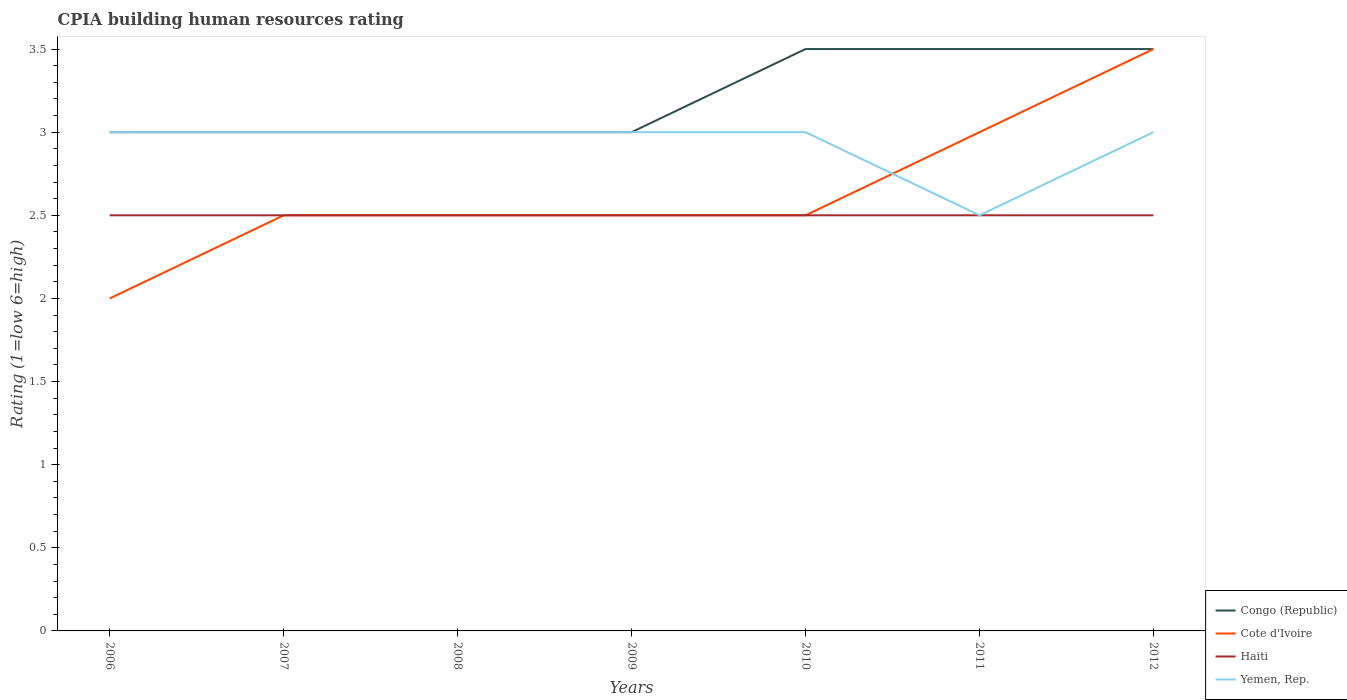Is the number of lines equal to the number of legend labels?
Provide a short and direct response. Yes. What is the total CPIA rating in Haiti in the graph?
Your answer should be very brief. 0. What is the difference between the highest and the second highest CPIA rating in Yemen, Rep.?
Offer a very short reply. 0.5. What is the difference between the highest and the lowest CPIA rating in Haiti?
Give a very brief answer. 0. How many years are there in the graph?
Offer a very short reply. 7. Does the graph contain grids?
Your answer should be compact. No. Where does the legend appear in the graph?
Offer a very short reply. Bottom right. What is the title of the graph?
Offer a very short reply. CPIA building human resources rating. What is the label or title of the X-axis?
Keep it short and to the point. Years. What is the label or title of the Y-axis?
Your response must be concise. Rating (1=low 6=high). What is the Rating (1=low 6=high) of Congo (Republic) in 2006?
Keep it short and to the point. 3. What is the Rating (1=low 6=high) in Cote d'Ivoire in 2006?
Keep it short and to the point. 2. What is the Rating (1=low 6=high) of Haiti in 2006?
Provide a short and direct response. 2.5. What is the Rating (1=low 6=high) in Yemen, Rep. in 2006?
Provide a succinct answer. 3. What is the Rating (1=low 6=high) of Congo (Republic) in 2007?
Your answer should be compact. 3. What is the Rating (1=low 6=high) in Cote d'Ivoire in 2007?
Ensure brevity in your answer.  2.5. What is the Rating (1=low 6=high) in Haiti in 2007?
Provide a short and direct response. 2.5. What is the Rating (1=low 6=high) in Congo (Republic) in 2008?
Your answer should be very brief. 3. What is the Rating (1=low 6=high) of Haiti in 2008?
Make the answer very short. 2.5. What is the Rating (1=low 6=high) in Yemen, Rep. in 2008?
Provide a succinct answer. 3. What is the Rating (1=low 6=high) in Congo (Republic) in 2009?
Your response must be concise. 3. What is the Rating (1=low 6=high) in Cote d'Ivoire in 2009?
Ensure brevity in your answer.  2.5. What is the Rating (1=low 6=high) in Yemen, Rep. in 2009?
Keep it short and to the point. 3. What is the Rating (1=low 6=high) in Congo (Republic) in 2011?
Your answer should be compact. 3.5. What is the Rating (1=low 6=high) of Cote d'Ivoire in 2011?
Make the answer very short. 3. What is the Rating (1=low 6=high) in Haiti in 2011?
Your answer should be very brief. 2.5. What is the Rating (1=low 6=high) of Yemen, Rep. in 2011?
Offer a terse response. 2.5. What is the Rating (1=low 6=high) in Cote d'Ivoire in 2012?
Offer a terse response. 3.5. What is the Rating (1=low 6=high) in Yemen, Rep. in 2012?
Give a very brief answer. 3. Across all years, what is the maximum Rating (1=low 6=high) in Yemen, Rep.?
Your answer should be very brief. 3. Across all years, what is the minimum Rating (1=low 6=high) of Cote d'Ivoire?
Keep it short and to the point. 2. Across all years, what is the minimum Rating (1=low 6=high) in Haiti?
Make the answer very short. 2.5. What is the total Rating (1=low 6=high) in Yemen, Rep. in the graph?
Keep it short and to the point. 20.5. What is the difference between the Rating (1=low 6=high) in Cote d'Ivoire in 2006 and that in 2007?
Your answer should be very brief. -0.5. What is the difference between the Rating (1=low 6=high) of Cote d'Ivoire in 2006 and that in 2008?
Your answer should be very brief. -0.5. What is the difference between the Rating (1=low 6=high) of Congo (Republic) in 2006 and that in 2009?
Ensure brevity in your answer.  0. What is the difference between the Rating (1=low 6=high) of Haiti in 2006 and that in 2009?
Provide a short and direct response. 0. What is the difference between the Rating (1=low 6=high) of Yemen, Rep. in 2006 and that in 2009?
Offer a very short reply. 0. What is the difference between the Rating (1=low 6=high) in Congo (Republic) in 2006 and that in 2010?
Provide a succinct answer. -0.5. What is the difference between the Rating (1=low 6=high) in Cote d'Ivoire in 2006 and that in 2010?
Offer a very short reply. -0.5. What is the difference between the Rating (1=low 6=high) in Yemen, Rep. in 2006 and that in 2010?
Your answer should be very brief. 0. What is the difference between the Rating (1=low 6=high) of Congo (Republic) in 2006 and that in 2011?
Your answer should be compact. -0.5. What is the difference between the Rating (1=low 6=high) of Cote d'Ivoire in 2006 and that in 2011?
Keep it short and to the point. -1. What is the difference between the Rating (1=low 6=high) in Congo (Republic) in 2006 and that in 2012?
Your response must be concise. -0.5. What is the difference between the Rating (1=low 6=high) in Cote d'Ivoire in 2006 and that in 2012?
Ensure brevity in your answer.  -1.5. What is the difference between the Rating (1=low 6=high) in Haiti in 2006 and that in 2012?
Keep it short and to the point. 0. What is the difference between the Rating (1=low 6=high) in Yemen, Rep. in 2006 and that in 2012?
Give a very brief answer. 0. What is the difference between the Rating (1=low 6=high) in Congo (Republic) in 2007 and that in 2008?
Your answer should be very brief. 0. What is the difference between the Rating (1=low 6=high) of Haiti in 2007 and that in 2008?
Give a very brief answer. 0. What is the difference between the Rating (1=low 6=high) of Congo (Republic) in 2007 and that in 2009?
Offer a terse response. 0. What is the difference between the Rating (1=low 6=high) of Congo (Republic) in 2007 and that in 2010?
Offer a terse response. -0.5. What is the difference between the Rating (1=low 6=high) of Yemen, Rep. in 2007 and that in 2010?
Your answer should be compact. 0. What is the difference between the Rating (1=low 6=high) in Congo (Republic) in 2007 and that in 2011?
Your response must be concise. -0.5. What is the difference between the Rating (1=low 6=high) of Cote d'Ivoire in 2007 and that in 2012?
Offer a terse response. -1. What is the difference between the Rating (1=low 6=high) of Congo (Republic) in 2008 and that in 2009?
Make the answer very short. 0. What is the difference between the Rating (1=low 6=high) in Cote d'Ivoire in 2008 and that in 2009?
Provide a succinct answer. 0. What is the difference between the Rating (1=low 6=high) of Yemen, Rep. in 2008 and that in 2009?
Provide a short and direct response. 0. What is the difference between the Rating (1=low 6=high) of Yemen, Rep. in 2008 and that in 2010?
Ensure brevity in your answer.  0. What is the difference between the Rating (1=low 6=high) in Haiti in 2008 and that in 2011?
Provide a succinct answer. 0. What is the difference between the Rating (1=low 6=high) of Yemen, Rep. in 2008 and that in 2011?
Provide a succinct answer. 0.5. What is the difference between the Rating (1=low 6=high) of Congo (Republic) in 2008 and that in 2012?
Your answer should be compact. -0.5. What is the difference between the Rating (1=low 6=high) of Cote d'Ivoire in 2008 and that in 2012?
Ensure brevity in your answer.  -1. What is the difference between the Rating (1=low 6=high) in Yemen, Rep. in 2008 and that in 2012?
Make the answer very short. 0. What is the difference between the Rating (1=low 6=high) in Congo (Republic) in 2009 and that in 2010?
Your answer should be very brief. -0.5. What is the difference between the Rating (1=low 6=high) of Haiti in 2009 and that in 2010?
Make the answer very short. 0. What is the difference between the Rating (1=low 6=high) of Yemen, Rep. in 2009 and that in 2010?
Give a very brief answer. 0. What is the difference between the Rating (1=low 6=high) of Cote d'Ivoire in 2009 and that in 2011?
Provide a short and direct response. -0.5. What is the difference between the Rating (1=low 6=high) in Haiti in 2009 and that in 2011?
Your answer should be compact. 0. What is the difference between the Rating (1=low 6=high) of Yemen, Rep. in 2009 and that in 2011?
Keep it short and to the point. 0.5. What is the difference between the Rating (1=low 6=high) in Haiti in 2010 and that in 2011?
Provide a succinct answer. 0. What is the difference between the Rating (1=low 6=high) of Yemen, Rep. in 2010 and that in 2011?
Keep it short and to the point. 0.5. What is the difference between the Rating (1=low 6=high) of Congo (Republic) in 2010 and that in 2012?
Provide a short and direct response. 0. What is the difference between the Rating (1=low 6=high) in Cote d'Ivoire in 2010 and that in 2012?
Your answer should be very brief. -1. What is the difference between the Rating (1=low 6=high) in Haiti in 2010 and that in 2012?
Offer a very short reply. 0. What is the difference between the Rating (1=low 6=high) in Yemen, Rep. in 2010 and that in 2012?
Offer a very short reply. 0. What is the difference between the Rating (1=low 6=high) of Congo (Republic) in 2011 and that in 2012?
Your answer should be very brief. 0. What is the difference between the Rating (1=low 6=high) in Haiti in 2011 and that in 2012?
Offer a very short reply. 0. What is the difference between the Rating (1=low 6=high) of Congo (Republic) in 2006 and the Rating (1=low 6=high) of Cote d'Ivoire in 2007?
Ensure brevity in your answer.  0.5. What is the difference between the Rating (1=low 6=high) in Congo (Republic) in 2006 and the Rating (1=low 6=high) in Haiti in 2007?
Ensure brevity in your answer.  0.5. What is the difference between the Rating (1=low 6=high) of Congo (Republic) in 2006 and the Rating (1=low 6=high) of Yemen, Rep. in 2007?
Your answer should be compact. 0. What is the difference between the Rating (1=low 6=high) of Congo (Republic) in 2006 and the Rating (1=low 6=high) of Cote d'Ivoire in 2008?
Your response must be concise. 0.5. What is the difference between the Rating (1=low 6=high) in Congo (Republic) in 2006 and the Rating (1=low 6=high) in Haiti in 2008?
Provide a short and direct response. 0.5. What is the difference between the Rating (1=low 6=high) of Cote d'Ivoire in 2006 and the Rating (1=low 6=high) of Haiti in 2008?
Provide a short and direct response. -0.5. What is the difference between the Rating (1=low 6=high) of Cote d'Ivoire in 2006 and the Rating (1=low 6=high) of Yemen, Rep. in 2008?
Offer a very short reply. -1. What is the difference between the Rating (1=low 6=high) in Haiti in 2006 and the Rating (1=low 6=high) in Yemen, Rep. in 2008?
Your answer should be very brief. -0.5. What is the difference between the Rating (1=low 6=high) of Congo (Republic) in 2006 and the Rating (1=low 6=high) of Cote d'Ivoire in 2009?
Provide a short and direct response. 0.5. What is the difference between the Rating (1=low 6=high) of Congo (Republic) in 2006 and the Rating (1=low 6=high) of Haiti in 2009?
Offer a very short reply. 0.5. What is the difference between the Rating (1=low 6=high) in Cote d'Ivoire in 2006 and the Rating (1=low 6=high) in Haiti in 2009?
Give a very brief answer. -0.5. What is the difference between the Rating (1=low 6=high) of Congo (Republic) in 2006 and the Rating (1=low 6=high) of Haiti in 2010?
Your answer should be very brief. 0.5. What is the difference between the Rating (1=low 6=high) of Congo (Republic) in 2006 and the Rating (1=low 6=high) of Yemen, Rep. in 2010?
Offer a terse response. 0. What is the difference between the Rating (1=low 6=high) of Cote d'Ivoire in 2006 and the Rating (1=low 6=high) of Haiti in 2010?
Provide a succinct answer. -0.5. What is the difference between the Rating (1=low 6=high) of Cote d'Ivoire in 2006 and the Rating (1=low 6=high) of Yemen, Rep. in 2010?
Offer a terse response. -1. What is the difference between the Rating (1=low 6=high) of Haiti in 2006 and the Rating (1=low 6=high) of Yemen, Rep. in 2010?
Provide a succinct answer. -0.5. What is the difference between the Rating (1=low 6=high) of Congo (Republic) in 2006 and the Rating (1=low 6=high) of Cote d'Ivoire in 2011?
Your response must be concise. 0. What is the difference between the Rating (1=low 6=high) in Congo (Republic) in 2006 and the Rating (1=low 6=high) in Haiti in 2011?
Your answer should be compact. 0.5. What is the difference between the Rating (1=low 6=high) in Cote d'Ivoire in 2006 and the Rating (1=low 6=high) in Haiti in 2011?
Offer a terse response. -0.5. What is the difference between the Rating (1=low 6=high) in Cote d'Ivoire in 2006 and the Rating (1=low 6=high) in Yemen, Rep. in 2011?
Offer a very short reply. -0.5. What is the difference between the Rating (1=low 6=high) of Haiti in 2006 and the Rating (1=low 6=high) of Yemen, Rep. in 2011?
Your response must be concise. 0. What is the difference between the Rating (1=low 6=high) in Congo (Republic) in 2006 and the Rating (1=low 6=high) in Haiti in 2012?
Ensure brevity in your answer.  0.5. What is the difference between the Rating (1=low 6=high) of Congo (Republic) in 2006 and the Rating (1=low 6=high) of Yemen, Rep. in 2012?
Ensure brevity in your answer.  0. What is the difference between the Rating (1=low 6=high) of Cote d'Ivoire in 2006 and the Rating (1=low 6=high) of Haiti in 2012?
Offer a terse response. -0.5. What is the difference between the Rating (1=low 6=high) in Cote d'Ivoire in 2006 and the Rating (1=low 6=high) in Yemen, Rep. in 2012?
Offer a very short reply. -1. What is the difference between the Rating (1=low 6=high) of Congo (Republic) in 2007 and the Rating (1=low 6=high) of Haiti in 2008?
Your response must be concise. 0.5. What is the difference between the Rating (1=low 6=high) of Congo (Republic) in 2007 and the Rating (1=low 6=high) of Yemen, Rep. in 2008?
Provide a succinct answer. 0. What is the difference between the Rating (1=low 6=high) of Cote d'Ivoire in 2007 and the Rating (1=low 6=high) of Yemen, Rep. in 2008?
Give a very brief answer. -0.5. What is the difference between the Rating (1=low 6=high) in Congo (Republic) in 2007 and the Rating (1=low 6=high) in Cote d'Ivoire in 2009?
Your answer should be very brief. 0.5. What is the difference between the Rating (1=low 6=high) in Congo (Republic) in 2007 and the Rating (1=low 6=high) in Haiti in 2009?
Ensure brevity in your answer.  0.5. What is the difference between the Rating (1=low 6=high) of Congo (Republic) in 2007 and the Rating (1=low 6=high) of Yemen, Rep. in 2009?
Offer a terse response. 0. What is the difference between the Rating (1=low 6=high) in Haiti in 2007 and the Rating (1=low 6=high) in Yemen, Rep. in 2009?
Your response must be concise. -0.5. What is the difference between the Rating (1=low 6=high) of Congo (Republic) in 2007 and the Rating (1=low 6=high) of Cote d'Ivoire in 2010?
Provide a succinct answer. 0.5. What is the difference between the Rating (1=low 6=high) of Congo (Republic) in 2007 and the Rating (1=low 6=high) of Haiti in 2010?
Ensure brevity in your answer.  0.5. What is the difference between the Rating (1=low 6=high) of Cote d'Ivoire in 2007 and the Rating (1=low 6=high) of Haiti in 2010?
Offer a very short reply. 0. What is the difference between the Rating (1=low 6=high) of Cote d'Ivoire in 2007 and the Rating (1=low 6=high) of Yemen, Rep. in 2010?
Provide a short and direct response. -0.5. What is the difference between the Rating (1=low 6=high) in Congo (Republic) in 2007 and the Rating (1=low 6=high) in Cote d'Ivoire in 2011?
Offer a very short reply. 0. What is the difference between the Rating (1=low 6=high) of Congo (Republic) in 2007 and the Rating (1=low 6=high) of Haiti in 2011?
Keep it short and to the point. 0.5. What is the difference between the Rating (1=low 6=high) in Congo (Republic) in 2007 and the Rating (1=low 6=high) in Cote d'Ivoire in 2012?
Offer a very short reply. -0.5. What is the difference between the Rating (1=low 6=high) of Congo (Republic) in 2007 and the Rating (1=low 6=high) of Haiti in 2012?
Give a very brief answer. 0.5. What is the difference between the Rating (1=low 6=high) of Cote d'Ivoire in 2007 and the Rating (1=low 6=high) of Haiti in 2012?
Your response must be concise. 0. What is the difference between the Rating (1=low 6=high) of Congo (Republic) in 2008 and the Rating (1=low 6=high) of Cote d'Ivoire in 2009?
Your answer should be very brief. 0.5. What is the difference between the Rating (1=low 6=high) in Congo (Republic) in 2008 and the Rating (1=low 6=high) in Haiti in 2009?
Offer a very short reply. 0.5. What is the difference between the Rating (1=low 6=high) of Cote d'Ivoire in 2008 and the Rating (1=low 6=high) of Haiti in 2009?
Give a very brief answer. 0. What is the difference between the Rating (1=low 6=high) in Cote d'Ivoire in 2008 and the Rating (1=low 6=high) in Yemen, Rep. in 2009?
Your response must be concise. -0.5. What is the difference between the Rating (1=low 6=high) of Congo (Republic) in 2008 and the Rating (1=low 6=high) of Cote d'Ivoire in 2010?
Offer a terse response. 0.5. What is the difference between the Rating (1=low 6=high) of Congo (Republic) in 2008 and the Rating (1=low 6=high) of Yemen, Rep. in 2010?
Ensure brevity in your answer.  0. What is the difference between the Rating (1=low 6=high) of Cote d'Ivoire in 2008 and the Rating (1=low 6=high) of Haiti in 2010?
Your answer should be very brief. 0. What is the difference between the Rating (1=low 6=high) of Cote d'Ivoire in 2008 and the Rating (1=low 6=high) of Yemen, Rep. in 2010?
Ensure brevity in your answer.  -0.5. What is the difference between the Rating (1=low 6=high) in Haiti in 2008 and the Rating (1=low 6=high) in Yemen, Rep. in 2010?
Provide a short and direct response. -0.5. What is the difference between the Rating (1=low 6=high) of Congo (Republic) in 2008 and the Rating (1=low 6=high) of Cote d'Ivoire in 2011?
Your answer should be very brief. 0. What is the difference between the Rating (1=low 6=high) in Cote d'Ivoire in 2008 and the Rating (1=low 6=high) in Haiti in 2011?
Provide a succinct answer. 0. What is the difference between the Rating (1=low 6=high) in Haiti in 2008 and the Rating (1=low 6=high) in Yemen, Rep. in 2012?
Provide a succinct answer. -0.5. What is the difference between the Rating (1=low 6=high) of Congo (Republic) in 2009 and the Rating (1=low 6=high) of Haiti in 2010?
Offer a very short reply. 0.5. What is the difference between the Rating (1=low 6=high) of Congo (Republic) in 2009 and the Rating (1=low 6=high) of Cote d'Ivoire in 2011?
Offer a very short reply. 0. What is the difference between the Rating (1=low 6=high) of Haiti in 2009 and the Rating (1=low 6=high) of Yemen, Rep. in 2011?
Your answer should be very brief. 0. What is the difference between the Rating (1=low 6=high) in Congo (Republic) in 2009 and the Rating (1=low 6=high) in Haiti in 2012?
Give a very brief answer. 0.5. What is the difference between the Rating (1=low 6=high) of Cote d'Ivoire in 2009 and the Rating (1=low 6=high) of Yemen, Rep. in 2012?
Your answer should be very brief. -0.5. What is the difference between the Rating (1=low 6=high) of Congo (Republic) in 2010 and the Rating (1=low 6=high) of Cote d'Ivoire in 2011?
Offer a terse response. 0.5. What is the difference between the Rating (1=low 6=high) of Congo (Republic) in 2010 and the Rating (1=low 6=high) of Haiti in 2011?
Offer a terse response. 1. What is the difference between the Rating (1=low 6=high) in Cote d'Ivoire in 2010 and the Rating (1=low 6=high) in Haiti in 2011?
Provide a succinct answer. 0. What is the difference between the Rating (1=low 6=high) in Cote d'Ivoire in 2010 and the Rating (1=low 6=high) in Yemen, Rep. in 2011?
Your response must be concise. 0. What is the difference between the Rating (1=low 6=high) of Congo (Republic) in 2010 and the Rating (1=low 6=high) of Cote d'Ivoire in 2012?
Make the answer very short. 0. What is the difference between the Rating (1=low 6=high) of Congo (Republic) in 2010 and the Rating (1=low 6=high) of Haiti in 2012?
Make the answer very short. 1. What is the difference between the Rating (1=low 6=high) in Cote d'Ivoire in 2010 and the Rating (1=low 6=high) in Yemen, Rep. in 2012?
Give a very brief answer. -0.5. What is the difference between the Rating (1=low 6=high) in Cote d'Ivoire in 2011 and the Rating (1=low 6=high) in Yemen, Rep. in 2012?
Give a very brief answer. 0. What is the difference between the Rating (1=low 6=high) in Haiti in 2011 and the Rating (1=low 6=high) in Yemen, Rep. in 2012?
Your response must be concise. -0.5. What is the average Rating (1=low 6=high) in Congo (Republic) per year?
Ensure brevity in your answer.  3.21. What is the average Rating (1=low 6=high) in Cote d'Ivoire per year?
Offer a very short reply. 2.64. What is the average Rating (1=low 6=high) in Yemen, Rep. per year?
Offer a terse response. 2.93. In the year 2006, what is the difference between the Rating (1=low 6=high) in Congo (Republic) and Rating (1=low 6=high) in Cote d'Ivoire?
Your response must be concise. 1. In the year 2006, what is the difference between the Rating (1=low 6=high) of Congo (Republic) and Rating (1=low 6=high) of Haiti?
Your answer should be very brief. 0.5. In the year 2006, what is the difference between the Rating (1=low 6=high) of Congo (Republic) and Rating (1=low 6=high) of Yemen, Rep.?
Make the answer very short. 0. In the year 2006, what is the difference between the Rating (1=low 6=high) in Cote d'Ivoire and Rating (1=low 6=high) in Yemen, Rep.?
Provide a short and direct response. -1. In the year 2007, what is the difference between the Rating (1=low 6=high) in Congo (Republic) and Rating (1=low 6=high) in Cote d'Ivoire?
Offer a very short reply. 0.5. In the year 2007, what is the difference between the Rating (1=low 6=high) of Congo (Republic) and Rating (1=low 6=high) of Haiti?
Provide a succinct answer. 0.5. In the year 2007, what is the difference between the Rating (1=low 6=high) in Congo (Republic) and Rating (1=low 6=high) in Yemen, Rep.?
Offer a terse response. 0. In the year 2007, what is the difference between the Rating (1=low 6=high) of Cote d'Ivoire and Rating (1=low 6=high) of Haiti?
Your response must be concise. 0. In the year 2007, what is the difference between the Rating (1=low 6=high) in Cote d'Ivoire and Rating (1=low 6=high) in Yemen, Rep.?
Offer a very short reply. -0.5. In the year 2008, what is the difference between the Rating (1=low 6=high) in Congo (Republic) and Rating (1=low 6=high) in Haiti?
Your answer should be compact. 0.5. In the year 2008, what is the difference between the Rating (1=low 6=high) of Cote d'Ivoire and Rating (1=low 6=high) of Haiti?
Make the answer very short. 0. In the year 2008, what is the difference between the Rating (1=low 6=high) in Haiti and Rating (1=low 6=high) in Yemen, Rep.?
Your answer should be compact. -0.5. In the year 2009, what is the difference between the Rating (1=low 6=high) in Congo (Republic) and Rating (1=low 6=high) in Haiti?
Offer a terse response. 0.5. In the year 2009, what is the difference between the Rating (1=low 6=high) in Cote d'Ivoire and Rating (1=low 6=high) in Haiti?
Provide a short and direct response. 0. In the year 2009, what is the difference between the Rating (1=low 6=high) in Cote d'Ivoire and Rating (1=low 6=high) in Yemen, Rep.?
Keep it short and to the point. -0.5. In the year 2011, what is the difference between the Rating (1=low 6=high) in Cote d'Ivoire and Rating (1=low 6=high) in Haiti?
Provide a short and direct response. 0.5. In the year 2011, what is the difference between the Rating (1=low 6=high) of Cote d'Ivoire and Rating (1=low 6=high) of Yemen, Rep.?
Offer a terse response. 0.5. In the year 2012, what is the difference between the Rating (1=low 6=high) in Congo (Republic) and Rating (1=low 6=high) in Cote d'Ivoire?
Keep it short and to the point. 0. In the year 2012, what is the difference between the Rating (1=low 6=high) in Congo (Republic) and Rating (1=low 6=high) in Haiti?
Your answer should be very brief. 1. What is the ratio of the Rating (1=low 6=high) of Congo (Republic) in 2006 to that in 2007?
Offer a very short reply. 1. What is the ratio of the Rating (1=low 6=high) of Haiti in 2006 to that in 2007?
Make the answer very short. 1. What is the ratio of the Rating (1=low 6=high) in Yemen, Rep. in 2006 to that in 2007?
Your answer should be very brief. 1. What is the ratio of the Rating (1=low 6=high) in Cote d'Ivoire in 2006 to that in 2008?
Provide a short and direct response. 0.8. What is the ratio of the Rating (1=low 6=high) of Cote d'Ivoire in 2006 to that in 2009?
Offer a terse response. 0.8. What is the ratio of the Rating (1=low 6=high) in Haiti in 2006 to that in 2009?
Give a very brief answer. 1. What is the ratio of the Rating (1=low 6=high) of Yemen, Rep. in 2006 to that in 2009?
Offer a terse response. 1. What is the ratio of the Rating (1=low 6=high) of Haiti in 2006 to that in 2010?
Keep it short and to the point. 1. What is the ratio of the Rating (1=low 6=high) of Yemen, Rep. in 2006 to that in 2010?
Keep it short and to the point. 1. What is the ratio of the Rating (1=low 6=high) of Cote d'Ivoire in 2006 to that in 2011?
Your answer should be very brief. 0.67. What is the ratio of the Rating (1=low 6=high) of Haiti in 2006 to that in 2011?
Your answer should be very brief. 1. What is the ratio of the Rating (1=low 6=high) of Cote d'Ivoire in 2006 to that in 2012?
Give a very brief answer. 0.57. What is the ratio of the Rating (1=low 6=high) in Yemen, Rep. in 2006 to that in 2012?
Offer a very short reply. 1. What is the ratio of the Rating (1=low 6=high) of Cote d'Ivoire in 2007 to that in 2009?
Make the answer very short. 1. What is the ratio of the Rating (1=low 6=high) in Haiti in 2007 to that in 2009?
Keep it short and to the point. 1. What is the ratio of the Rating (1=low 6=high) in Congo (Republic) in 2007 to that in 2010?
Ensure brevity in your answer.  0.86. What is the ratio of the Rating (1=low 6=high) in Congo (Republic) in 2007 to that in 2012?
Offer a very short reply. 0.86. What is the ratio of the Rating (1=low 6=high) of Yemen, Rep. in 2007 to that in 2012?
Keep it short and to the point. 1. What is the ratio of the Rating (1=low 6=high) in Congo (Republic) in 2008 to that in 2009?
Keep it short and to the point. 1. What is the ratio of the Rating (1=low 6=high) in Yemen, Rep. in 2008 to that in 2009?
Offer a very short reply. 1. What is the ratio of the Rating (1=low 6=high) in Congo (Republic) in 2008 to that in 2010?
Make the answer very short. 0.86. What is the ratio of the Rating (1=low 6=high) of Haiti in 2008 to that in 2010?
Offer a terse response. 1. What is the ratio of the Rating (1=low 6=high) of Cote d'Ivoire in 2008 to that in 2011?
Offer a very short reply. 0.83. What is the ratio of the Rating (1=low 6=high) in Haiti in 2008 to that in 2011?
Ensure brevity in your answer.  1. What is the ratio of the Rating (1=low 6=high) in Yemen, Rep. in 2008 to that in 2011?
Ensure brevity in your answer.  1.2. What is the ratio of the Rating (1=low 6=high) in Congo (Republic) in 2008 to that in 2012?
Provide a succinct answer. 0.86. What is the ratio of the Rating (1=low 6=high) in Cote d'Ivoire in 2008 to that in 2012?
Your answer should be very brief. 0.71. What is the ratio of the Rating (1=low 6=high) of Yemen, Rep. in 2008 to that in 2012?
Provide a succinct answer. 1. What is the ratio of the Rating (1=low 6=high) in Congo (Republic) in 2009 to that in 2010?
Provide a short and direct response. 0.86. What is the ratio of the Rating (1=low 6=high) in Haiti in 2009 to that in 2010?
Provide a succinct answer. 1. What is the ratio of the Rating (1=low 6=high) of Yemen, Rep. in 2009 to that in 2010?
Offer a terse response. 1. What is the ratio of the Rating (1=low 6=high) of Cote d'Ivoire in 2009 to that in 2011?
Provide a short and direct response. 0.83. What is the ratio of the Rating (1=low 6=high) in Congo (Republic) in 2009 to that in 2012?
Give a very brief answer. 0.86. What is the ratio of the Rating (1=low 6=high) of Yemen, Rep. in 2009 to that in 2012?
Offer a terse response. 1. What is the ratio of the Rating (1=low 6=high) of Congo (Republic) in 2010 to that in 2011?
Provide a short and direct response. 1. What is the ratio of the Rating (1=low 6=high) in Cote d'Ivoire in 2010 to that in 2011?
Give a very brief answer. 0.83. What is the ratio of the Rating (1=low 6=high) in Haiti in 2010 to that in 2011?
Your response must be concise. 1. What is the ratio of the Rating (1=low 6=high) in Congo (Republic) in 2010 to that in 2012?
Offer a very short reply. 1. What is the ratio of the Rating (1=low 6=high) of Cote d'Ivoire in 2010 to that in 2012?
Provide a succinct answer. 0.71. What is the ratio of the Rating (1=low 6=high) in Yemen, Rep. in 2010 to that in 2012?
Your response must be concise. 1. What is the ratio of the Rating (1=low 6=high) in Cote d'Ivoire in 2011 to that in 2012?
Your answer should be compact. 0.86. What is the difference between the highest and the second highest Rating (1=low 6=high) of Yemen, Rep.?
Offer a very short reply. 0. What is the difference between the highest and the lowest Rating (1=low 6=high) in Congo (Republic)?
Give a very brief answer. 0.5. 